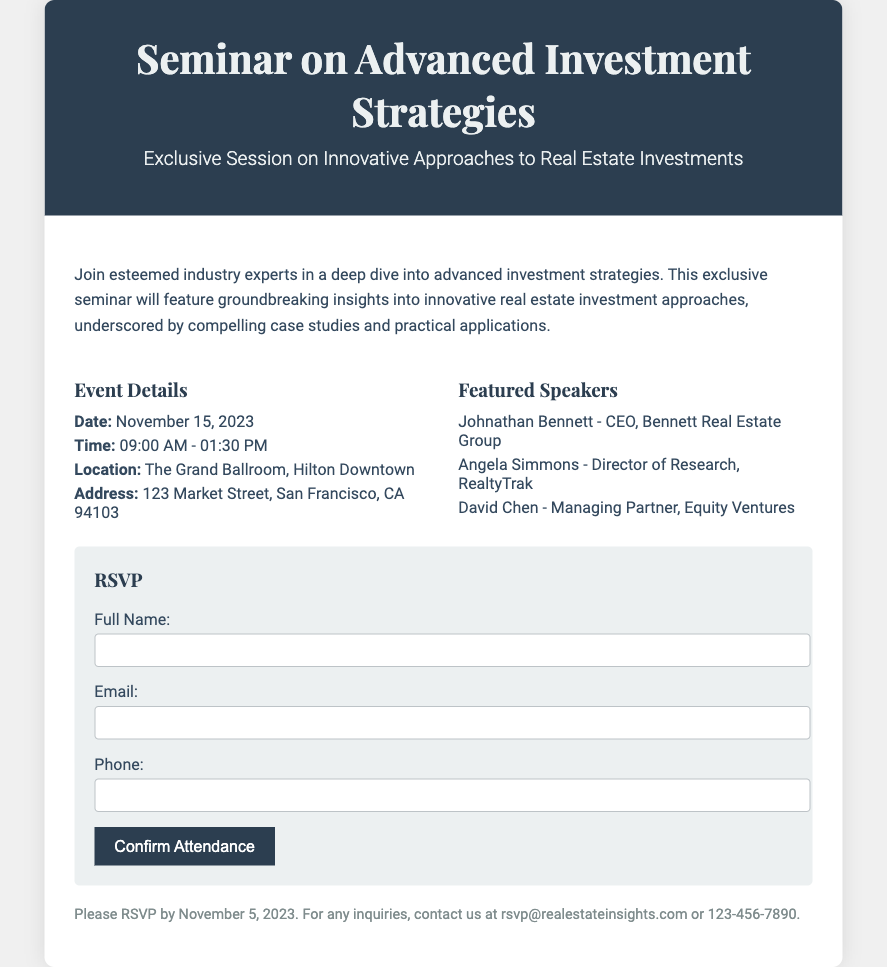What is the date of the seminar? The date of the seminar is clearly mentioned in the details section of the document, which states November 15, 2023.
Answer: November 15, 2023 Who is the CEO of Bennett Real Estate Group? The featured speakers section provides the name of Johnathan Bennett as the CEO of Bennett Real Estate Group.
Answer: Johnathan Bennett What time does the seminar start? The start time of the seminar is noted in the event details as 09:00 AM.
Answer: 09:00 AM What is the location of the seminar? The document specifies The Grand Ballroom, Hilton Downtown as the location for the seminar.
Answer: The Grand Ballroom, Hilton Downtown What is the RSVP deadline? The RSVP deadline is mentioned at the end of the document as November 5, 2023.
Answer: November 5, 2023 How many featured speakers are listed? The document lists three featured speakers in the designated section, confirming there are three.
Answer: Three What method is provided for inquiries? The document provides an email address and phone number for inquiries, specifically listing rsvp@realestateinsights.com.
Answer: rsvp@realestateinsights.com What type of event is this document related to? The document is about a seminar, as indicated in the title and introductory description.
Answer: Seminar How long is the seminar scheduled to last? The seminar time provided in the document indicates it lasts from 09:00 AM to 01:30 PM, which is a total of 4.5 hours.
Answer: 4.5 hours 